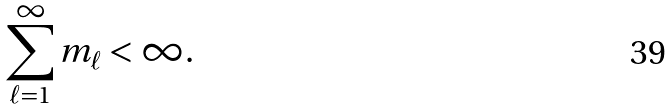<formula> <loc_0><loc_0><loc_500><loc_500>\sum _ { \ell = 1 } ^ { \infty } m _ { \ell } < \infty .</formula> 